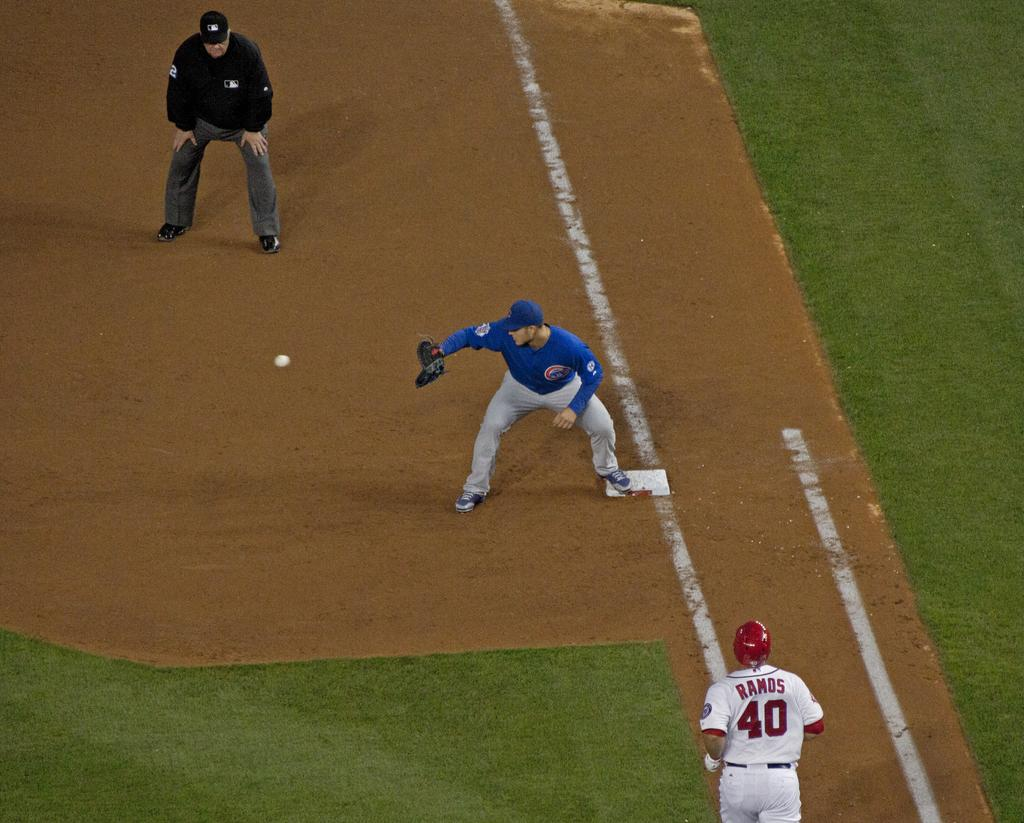<image>
Present a compact description of the photo's key features. a baseball player named Ramos running to first base 